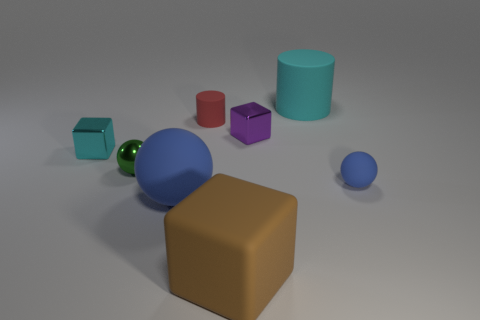Add 2 large green matte cylinders. How many objects exist? 10 Subtract all cylinders. How many objects are left? 6 Add 8 tiny brown shiny cylinders. How many tiny brown shiny cylinders exist? 8 Subtract 0 gray spheres. How many objects are left? 8 Subtract all tiny metallic cubes. Subtract all tiny red matte cylinders. How many objects are left? 5 Add 7 large balls. How many large balls are left? 8 